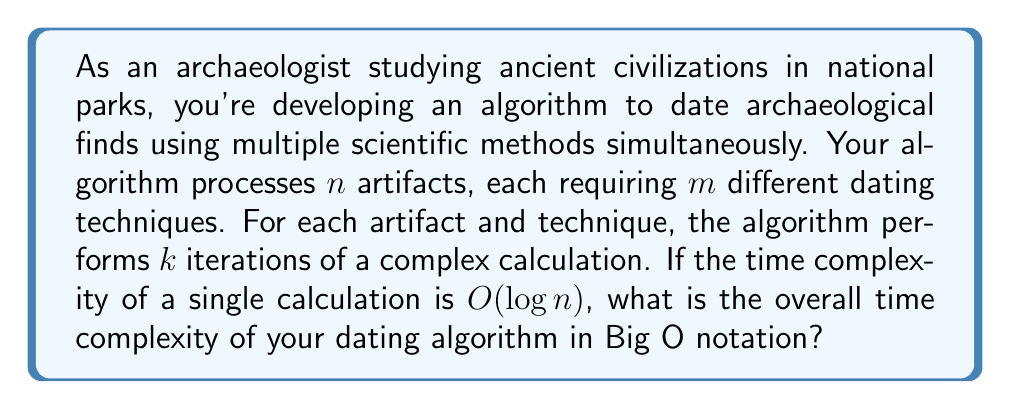Solve this math problem. To determine the overall time complexity of the dating algorithm, we need to analyze the nested structure of the operations:

1. The outermost loop processes $n$ artifacts.
2. For each artifact, there are $m$ different dating techniques.
3. Each technique requires $k$ iterations of a complex calculation.
4. The time complexity of a single calculation is $O(\log n)$.

Let's break down the complexity analysis step by step:

1. The innermost operation (the complex calculation) has a time complexity of $O(\log n)$.

2. This calculation is repeated $k$ times for each technique:
   $O(k \cdot \log n)$

3. There are $m$ techniques for each artifact:
   $O(m \cdot k \cdot \log n)$

4. Finally, this process is repeated for all $n$ artifacts:
   $O(n \cdot m \cdot k \cdot \log n)$

In Big O notation, we typically don't include constant factors (like $k$) unless they're particularly significant. Since $m$ could vary independently of $n$, we keep it in our notation.

Therefore, the overall time complexity of the dating algorithm is $O(n \cdot m \cdot \log n)$.

This complexity reflects that the algorithm's running time grows linearly with the number of artifacts $(n)$ and dating techniques $(m)$, and logarithmically with the size of the input for each calculation $(\log n)$.
Answer: $O(n \cdot m \cdot \log n)$ 